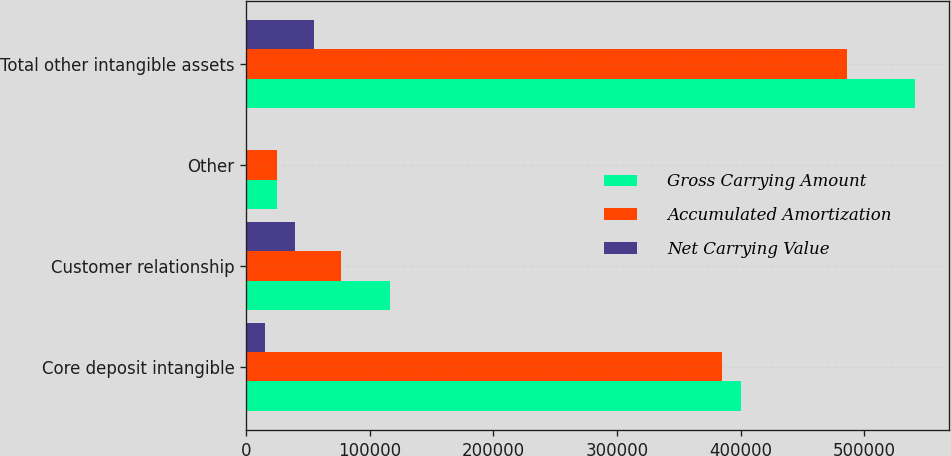Convert chart to OTSL. <chart><loc_0><loc_0><loc_500><loc_500><stacked_bar_chart><ecel><fcel>Core deposit intangible<fcel>Customer relationship<fcel>Other<fcel>Total other intangible assets<nl><fcel>Gross Carrying Amount<fcel>400058<fcel>116094<fcel>25164<fcel>541316<nl><fcel>Accumulated Amortization<fcel>384606<fcel>76656<fcel>25076<fcel>486338<nl><fcel>Net Carrying Value<fcel>15452<fcel>39438<fcel>88<fcel>54978<nl></chart> 